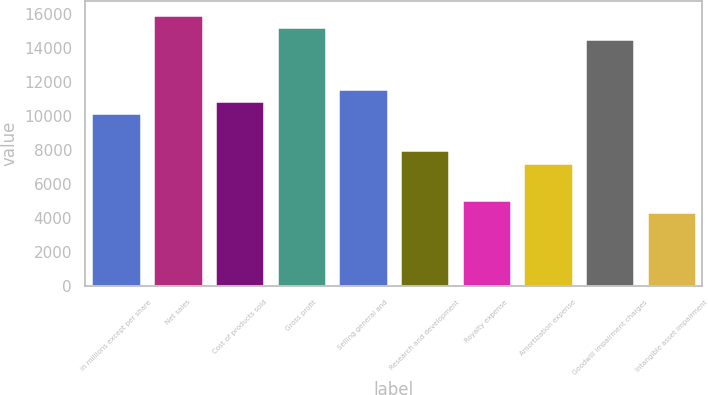<chart> <loc_0><loc_0><loc_500><loc_500><bar_chart><fcel>in millions except per share<fcel>Net sales<fcel>Cost of products sold<fcel>Gross profit<fcel>Selling general and<fcel>Research and development<fcel>Royalty expense<fcel>Amortization expense<fcel>Goodwill impairment charges<fcel>Intangible asset impairment<nl><fcel>10147.4<fcel>15944.3<fcel>10872<fcel>15219.7<fcel>11596.6<fcel>7973.6<fcel>5075.16<fcel>7248.99<fcel>14495.1<fcel>4350.55<nl></chart> 